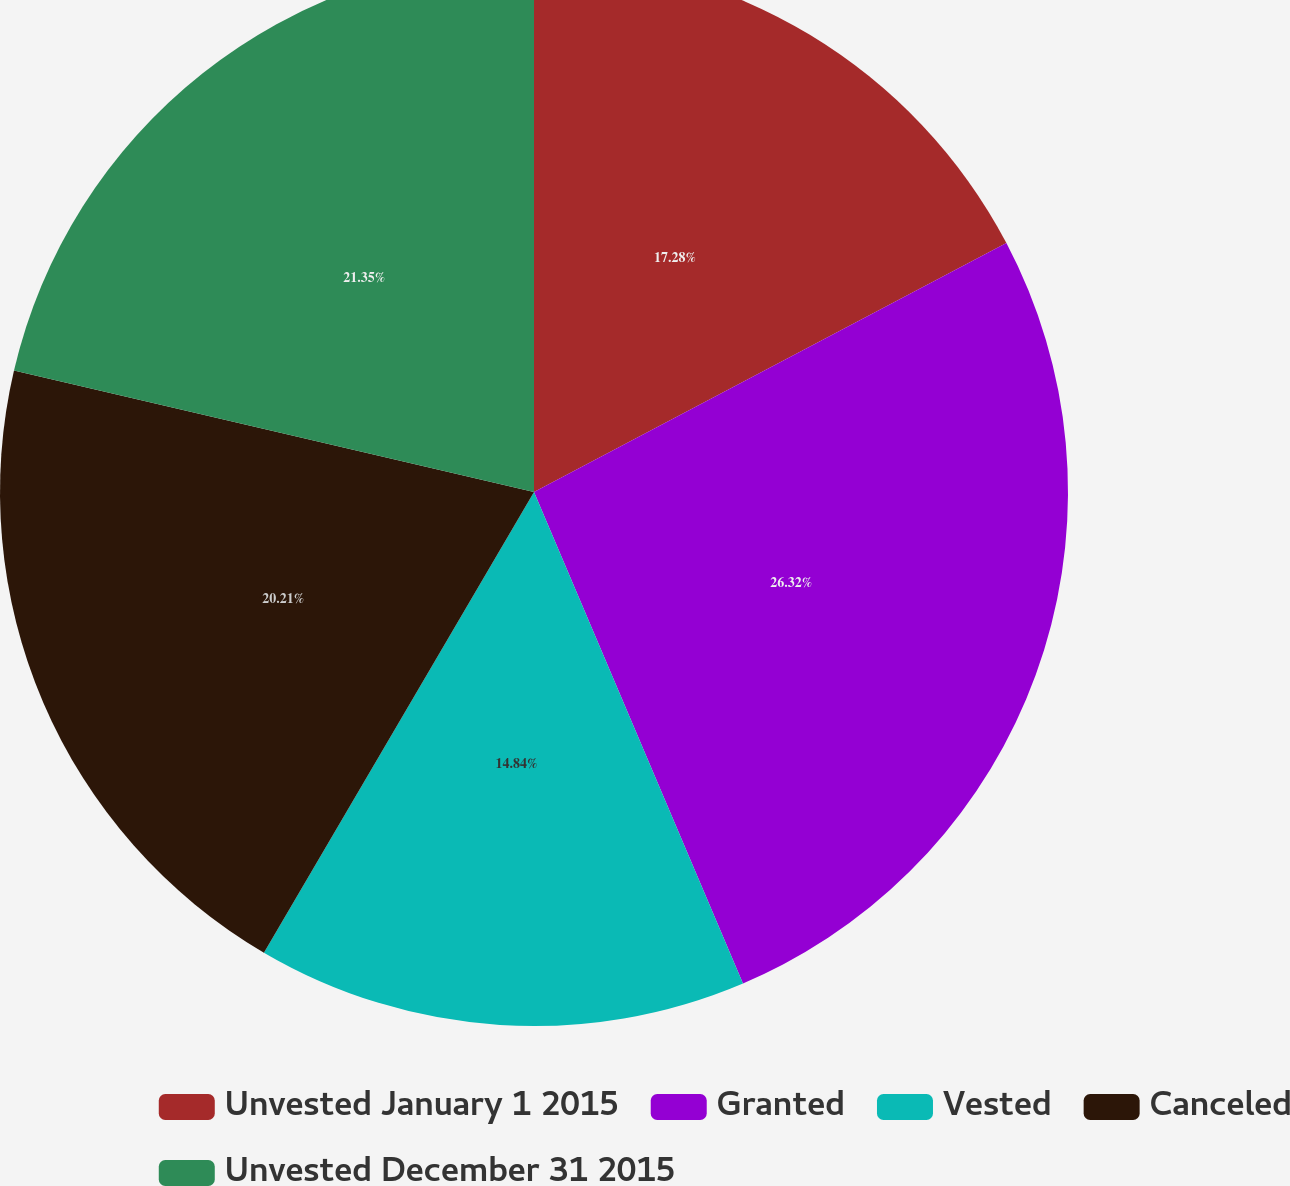Convert chart to OTSL. <chart><loc_0><loc_0><loc_500><loc_500><pie_chart><fcel>Unvested January 1 2015<fcel>Granted<fcel>Vested<fcel>Canceled<fcel>Unvested December 31 2015<nl><fcel>17.28%<fcel>26.32%<fcel>14.84%<fcel>20.21%<fcel>21.35%<nl></chart> 